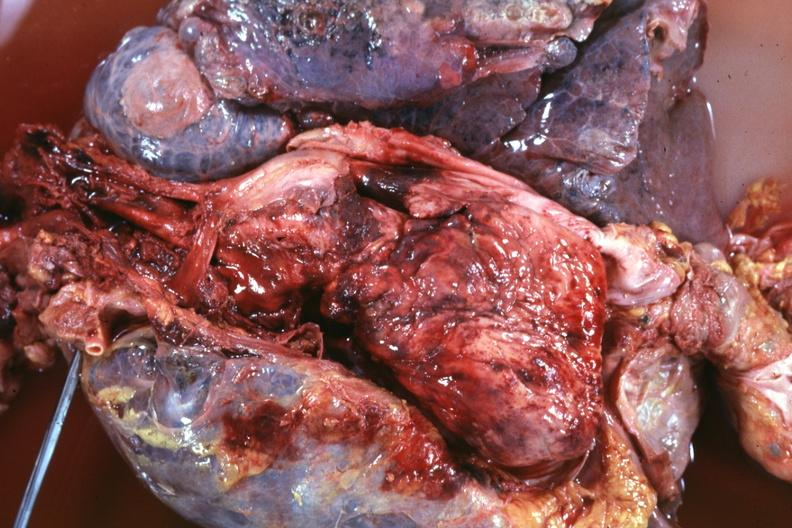s endometritis present?
Answer the question using a single word or phrase. No 